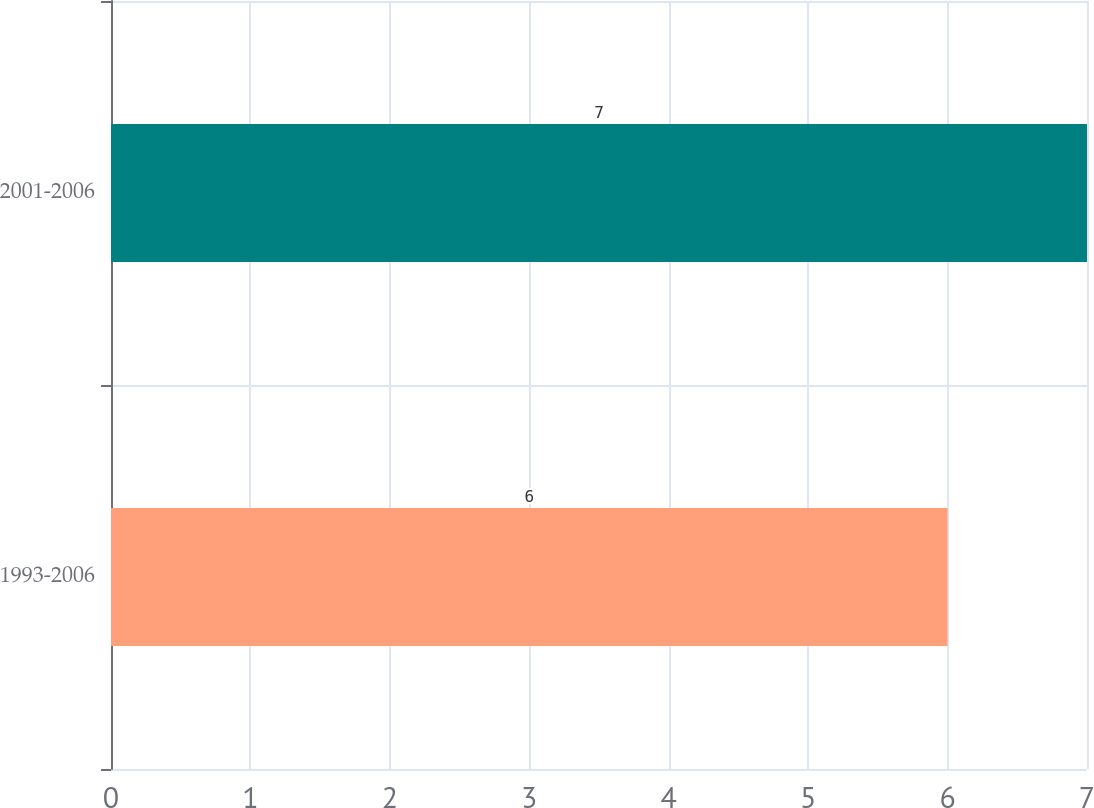Convert chart to OTSL. <chart><loc_0><loc_0><loc_500><loc_500><bar_chart><fcel>1993-2006<fcel>2001-2006<nl><fcel>6<fcel>7<nl></chart> 